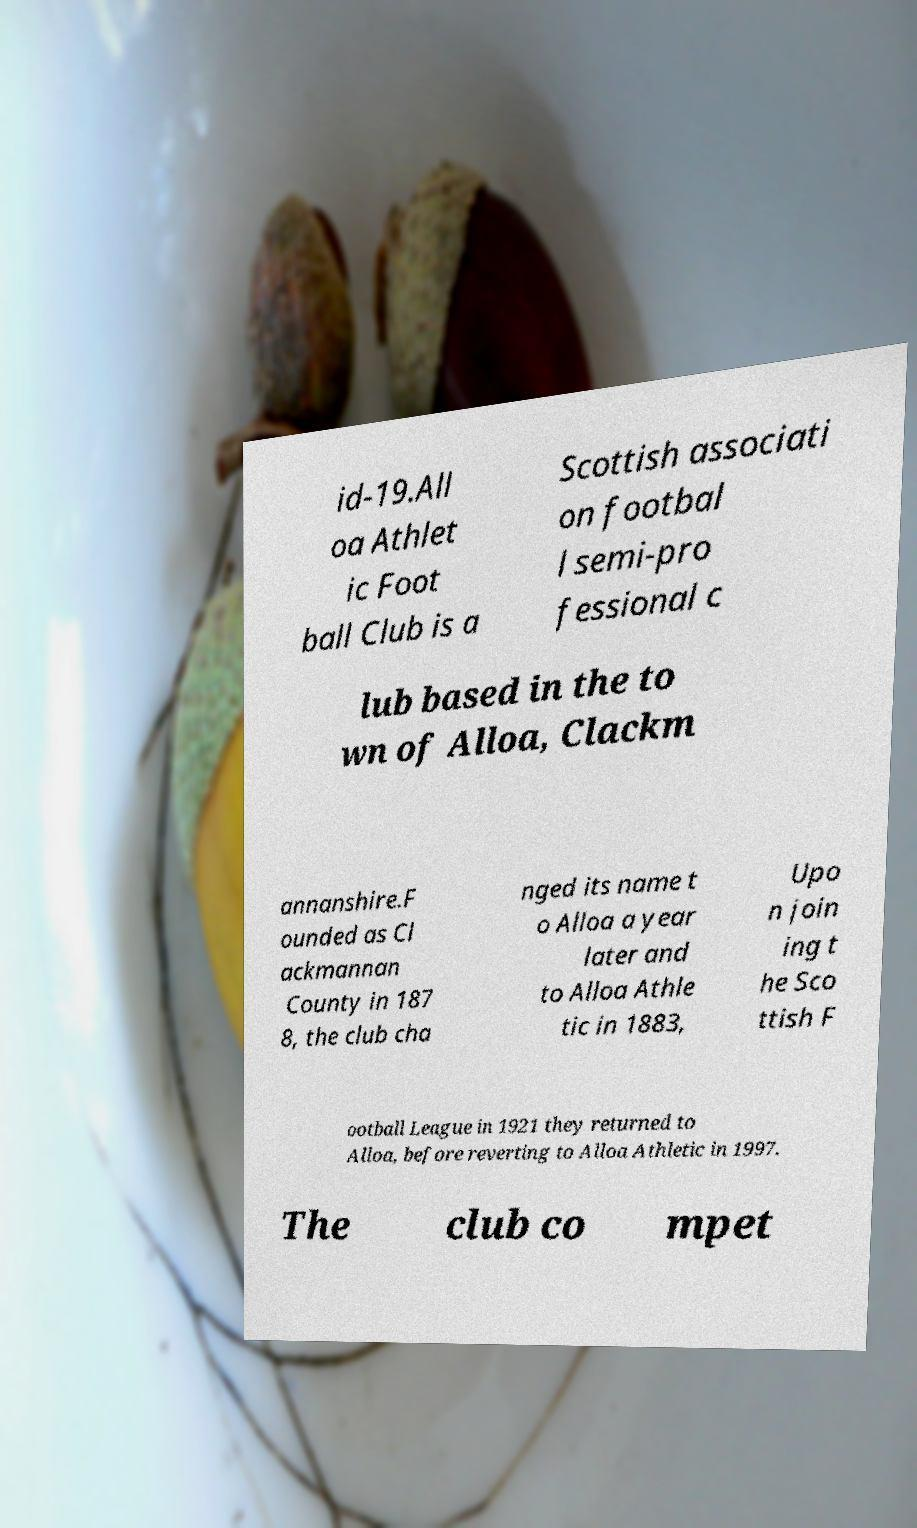Could you extract and type out the text from this image? id-19.All oa Athlet ic Foot ball Club is a Scottish associati on footbal l semi-pro fessional c lub based in the to wn of Alloa, Clackm annanshire.F ounded as Cl ackmannan County in 187 8, the club cha nged its name t o Alloa a year later and to Alloa Athle tic in 1883, Upo n join ing t he Sco ttish F ootball League in 1921 they returned to Alloa, before reverting to Alloa Athletic in 1997. The club co mpet 